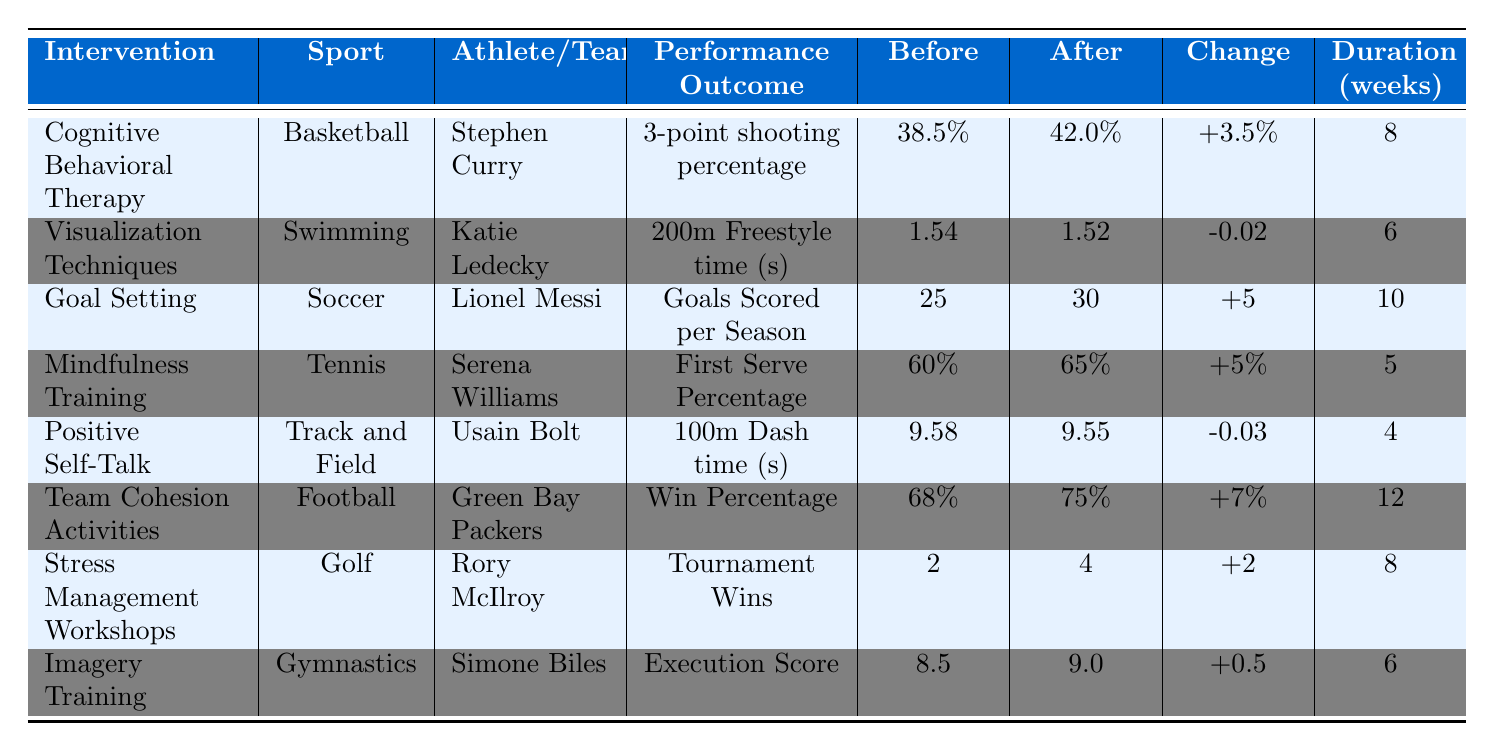What is the performance outcome for Stephen Curry after Cognitive Behavioral Therapy? The table shows that Stephen Curry's performance outcome after the intervention is a 3-point shooting percentage of 42.0%.
Answer: 42.0% How many weeks did it take for Usain Bolt to see a change in his 100m Dash time? Usain Bolt's positive self-talk intervention lasted for 4 weeks before a change was observed.
Answer: 4 What was the increase in goals scored per season for Lionel Messi after goal setting? The table indicates that Lionel Messi's goals scored per season increased from 25 to 30, which is an increase of 5 goals.
Answer: 5 Did Serena Williams' first serve percentage improve after mindfulness training? Yes, Serena Williams' first serve percentage improved from 60% to 65% after the intervention.
Answer: Yes What is the average change in performance outcomes across all athletes listed? The changes are +3.5, -0.02, +5, +5, -0.03, +7, +2, +0.5. Their sum is 3.5 + -0.02 + 5 + 5 + -0.03 + 7 + 2 + 0.5 = 23.92. Dividing by 8 (the number of interventions), the average change is 23.92 / 8 = 2.99.
Answer: 2.99 Which intervention led to the highest percentage increase in performance outcome? The highest percentage increase is seen with the Green Bay Packers’ win percentage, which increased from 68% to 75%. This is a change of +7%, the largest among all interventions.
Answer: +7% What was the performance outcome of Rory McIlroy before the stress management workshops? The table indicates that before the workshops, Rory McIlroy had 2 tournament wins.
Answer: 2 Was there a decrease in performance outcome for any athlete after their respective intervention? Yes, Usain Bolt's 100m Dash time decreased from 9.58 seconds to 9.55 seconds, indicating a performance improvement, but it is presented as a negative change.
Answer: Yes How did Katie Ledecky's 200m Freestyle time change after visualization techniques? Katie Ledecky's time improved from 1.54 seconds to 1.52 seconds, resulting in a change of -0.02 seconds.
Answer: -0.02 Which sport saw the greatest duration for its intervention, and what was the intervention type? The greatest duration was for the Football intervention (Team Cohesion Activities), lasting 12 weeks.
Answer: 12 weeks, Team Cohesion Activities 